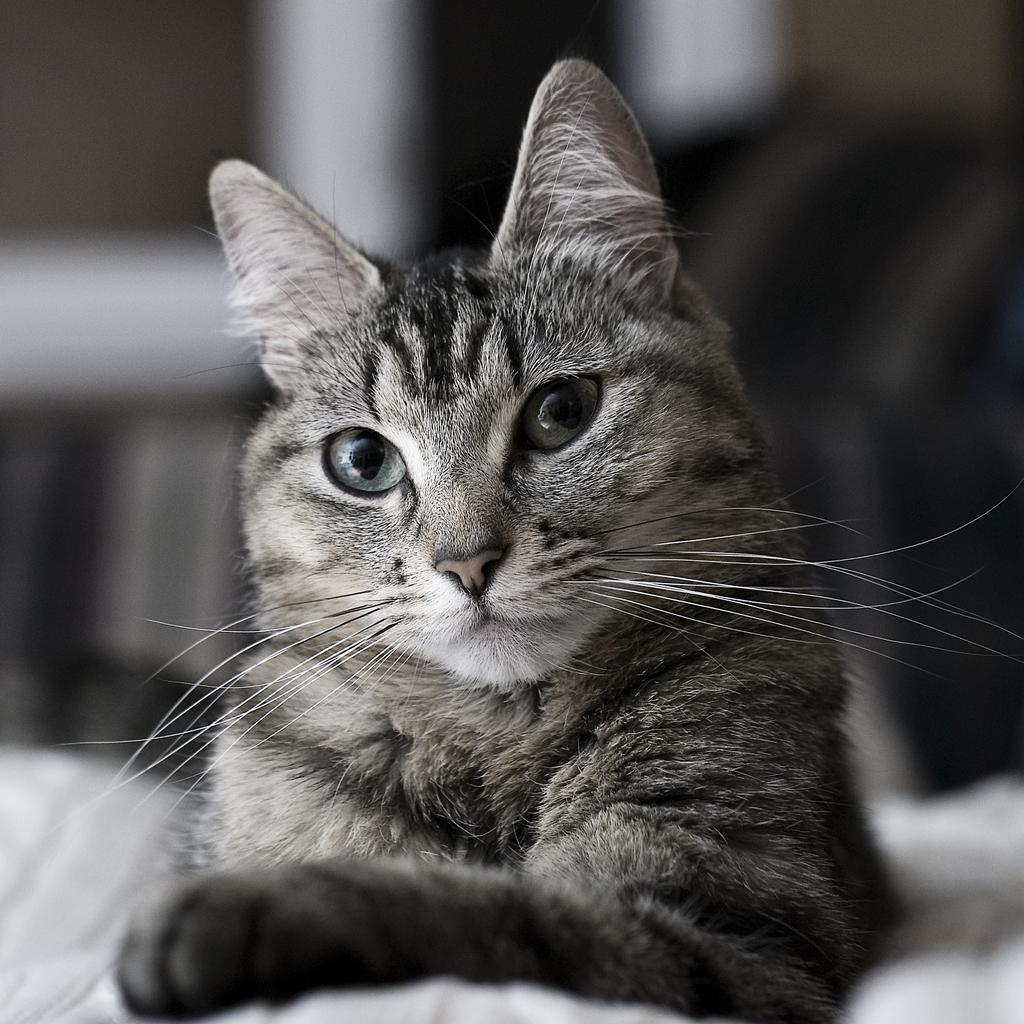What type of animal is in the image? There is a cat in the image. What colors does the cat have? The cat is black and white. Can you describe the background of the image? The background of the image is blurred. What type of soda is the cat drinking in the image? There is no soda present in the image; it features a black and white cat with a blurred background. What is the cat's head doing in the image? The cat's head is not performing any specific action in the image; it is simply part of the cat's body. 